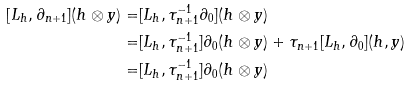<formula> <loc_0><loc_0><loc_500><loc_500>[ L _ { h } , \partial _ { n + 1 } ] ( { h } \otimes y ) = & [ L _ { h } , \tau _ { n + 1 } ^ { - 1 } \partial _ { 0 } ] ( { h } \otimes y ) \\ = & [ L _ { h } , \tau _ { n + 1 } ^ { - 1 } ] \partial _ { 0 } ( { h } \otimes y ) + \tau _ { n + 1 } [ L _ { h } , \partial _ { 0 } ] ( { h } , y ) \\ = & [ L _ { h } , \tau _ { n + 1 } ^ { - 1 } ] \partial _ { 0 } ( { h } \otimes y )</formula> 